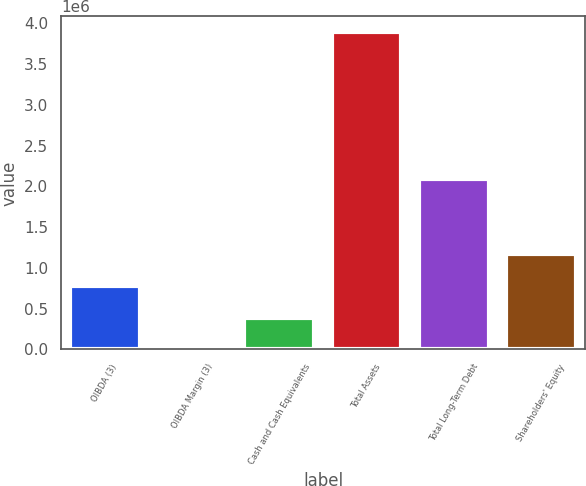<chart> <loc_0><loc_0><loc_500><loc_500><bar_chart><fcel>OIBDA (3)<fcel>OIBDA Margin (3)<fcel>Cash and Cash Equivalents<fcel>Total Assets<fcel>Total Long-Term Debt<fcel>Shareholders' Equity<nl><fcel>778443<fcel>29<fcel>389236<fcel>3.8921e+06<fcel>2.08993e+06<fcel>1.16765e+06<nl></chart> 